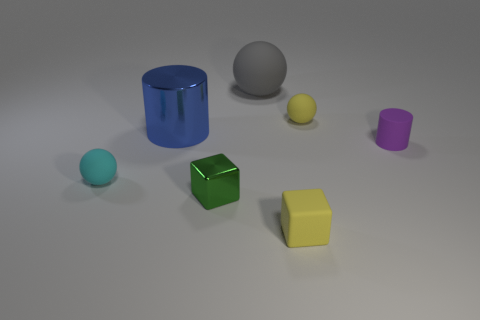Do the small matte cube and the small matte sphere behind the cyan rubber sphere have the same color?
Your answer should be compact. Yes. There is a large thing that is in front of the gray matte ball; is its shape the same as the large rubber object?
Offer a very short reply. No. Is the number of yellow rubber objects in front of the shiny cube greater than the number of blue objects that are in front of the yellow cube?
Your answer should be compact. Yes. There is a metal thing to the right of the big cylinder; how many shiny things are behind it?
Give a very brief answer. 1. What is the material of the ball that is the same color as the tiny matte block?
Make the answer very short. Rubber. What number of other things are the same color as the big metallic thing?
Your answer should be very brief. 0. The small ball in front of the small ball behind the cyan ball is what color?
Ensure brevity in your answer.  Cyan. Are there any tiny cubes that have the same color as the tiny matte cylinder?
Keep it short and to the point. No. What number of matte objects are either tiny green cylinders or green things?
Offer a terse response. 0. Are there any blue objects that have the same material as the tiny green cube?
Provide a short and direct response. Yes. 